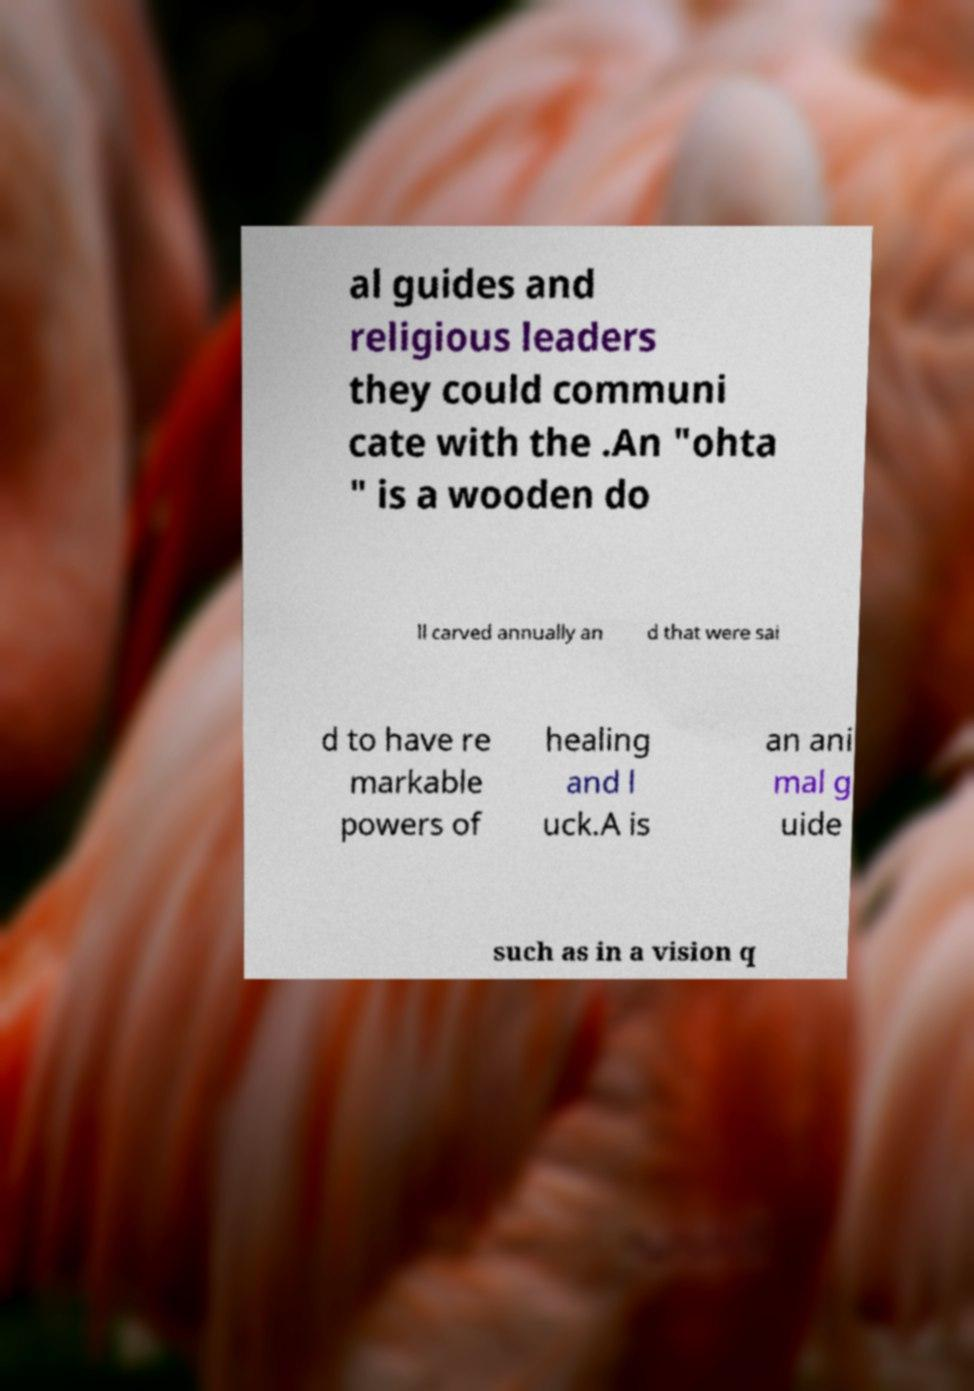Please identify and transcribe the text found in this image. al guides and religious leaders they could communi cate with the .An "ohta " is a wooden do ll carved annually an d that were sai d to have re markable powers of healing and l uck.A is an ani mal g uide such as in a vision q 